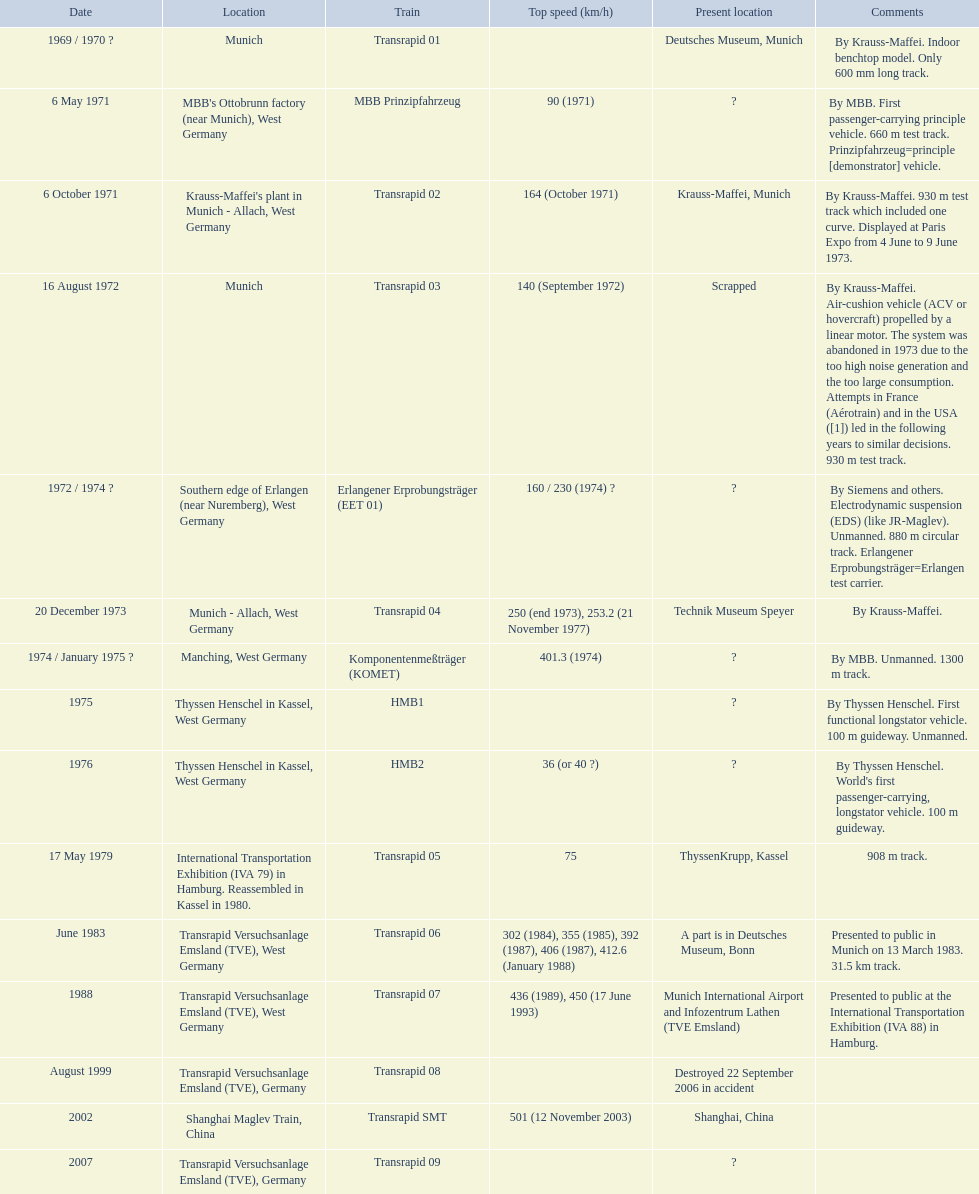Which trains exceeded a top speed of 400+? Komponentenmeßträger (KOMET), Transrapid 07, Transrapid SMT. How about 500+? Transrapid SMT. 